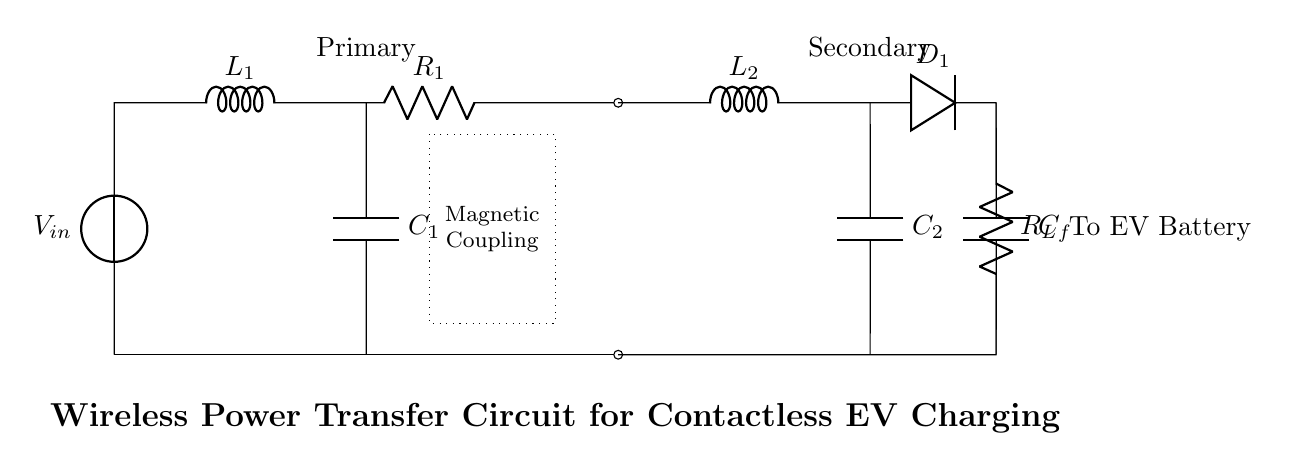What is the input voltage of this circuit? The circuit shows a voltage source labeled as V_in at the primary side, which represents the input voltage for wireless power transfer.
Answer: V_in What is the resonant inductor on the primary side? The circuit diagram labels the inductor on the primary side with L_1, indicating it serves as the resonant component for energy transfer.
Answer: L_1 How many capacitors are used in this circuit? The circuit diagram displays two capacitors, C_1 on the primary side and C_2 on the secondary side, indicating the use of two capacitors for resonance.
Answer: Two What is the function of the magnetic coupling in this circuit? The dotted rectangle represents magnetic coupling between the primary and secondary sides, enabling the transfer of energy without direct electrical connections.
Answer: Energy transfer What is the role of the diode in the secondary circuit? The diode labeled D_1 allows current to flow in only one direction, providing rectification which is necessary for converting AC to DC for charging the EV battery.
Answer: Rectification What is the load represented in the circuit? The resistor labeled R_L on the secondary side indicates the load component, which represents the electrical load that the circuit is driving, such as the EV battery.
Answer: R_L What does the capacitor C_f do in the secondary circuit? The capacitor C_f is used to filter and stabilize the output voltage across the load, improving efficiency and performance during wireless power transfer.
Answer: Filtering 